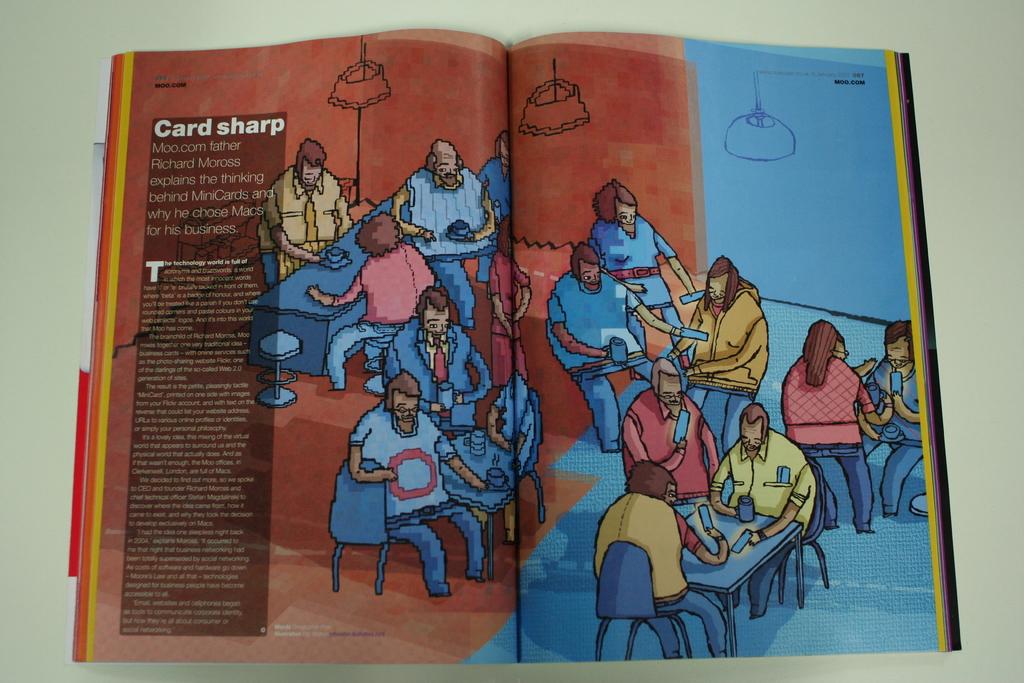What is the name of the article?
Give a very brief answer. Card sharp. What is that website written on the pages?
Ensure brevity in your answer.  Unanswerable. 